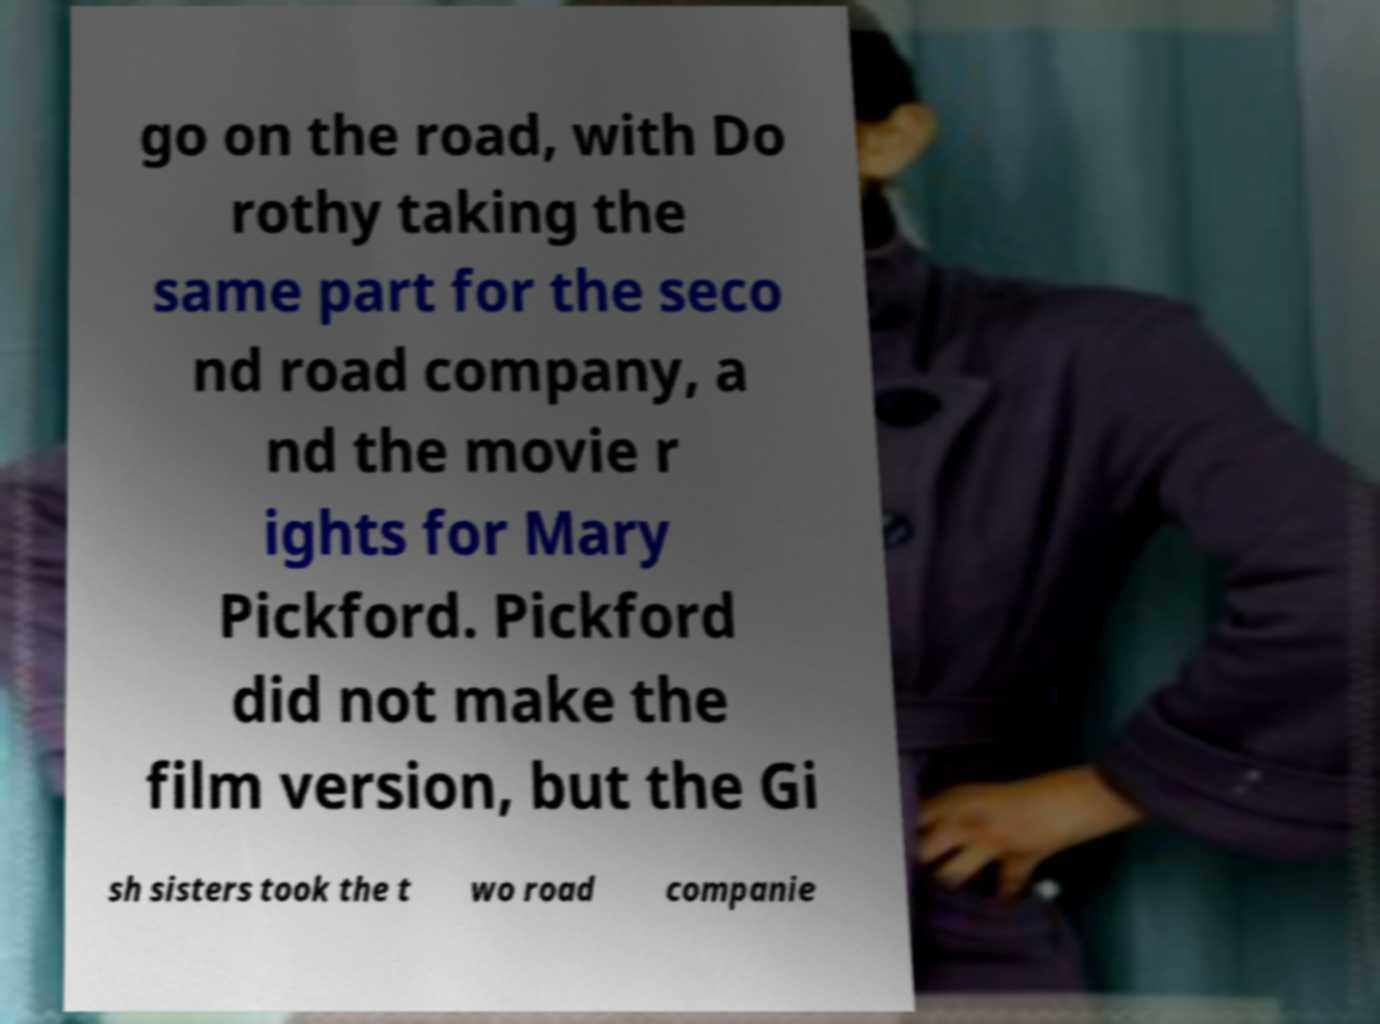There's text embedded in this image that I need extracted. Can you transcribe it verbatim? go on the road, with Do rothy taking the same part for the seco nd road company, a nd the movie r ights for Mary Pickford. Pickford did not make the film version, but the Gi sh sisters took the t wo road companie 